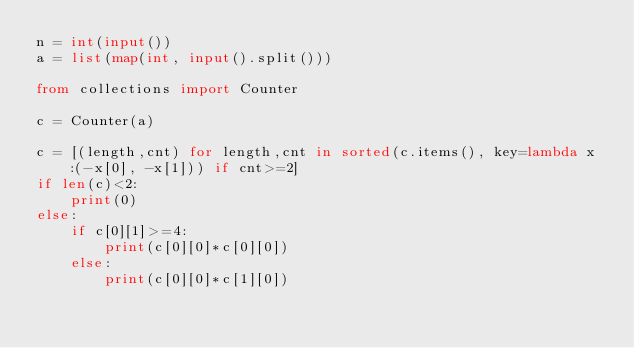Convert code to text. <code><loc_0><loc_0><loc_500><loc_500><_Python_>n = int(input())
a = list(map(int, input().split()))

from collections import Counter

c = Counter(a)

c = [(length,cnt) for length,cnt in sorted(c.items(), key=lambda x:(-x[0], -x[1])) if cnt>=2]
if len(c)<2:
    print(0)
else:
    if c[0][1]>=4:
        print(c[0][0]*c[0][0])
    else:
        print(c[0][0]*c[1][0])</code> 